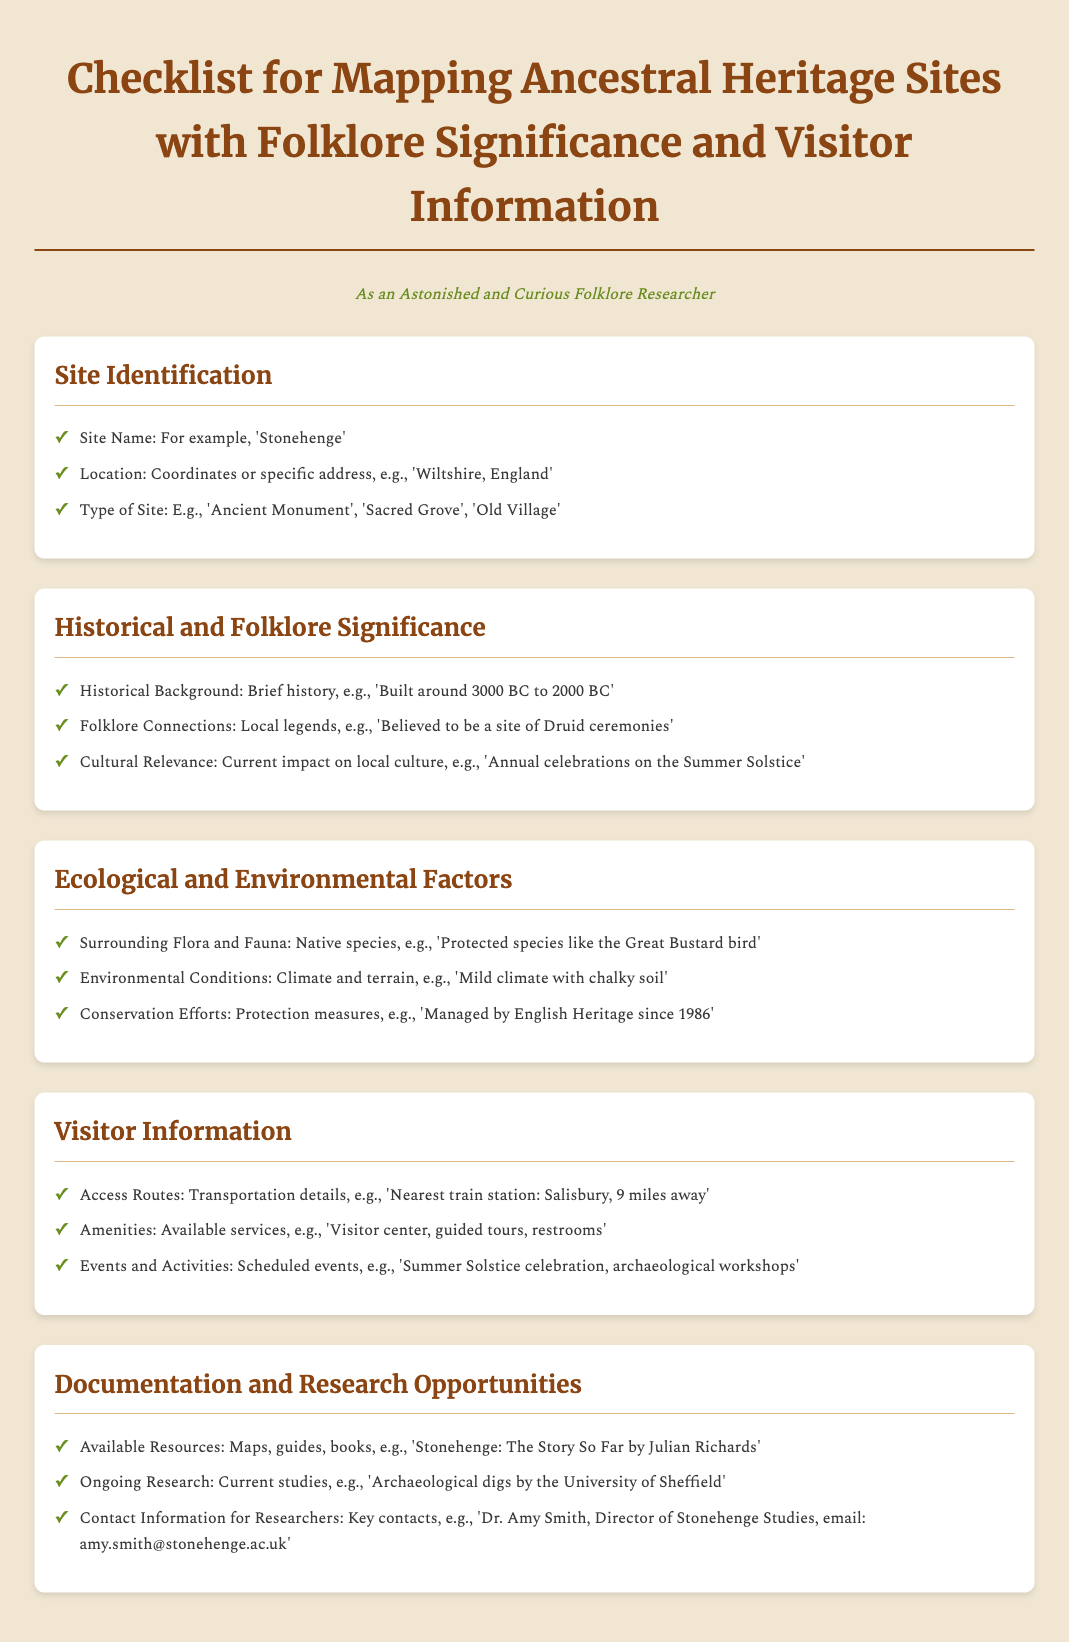What is an example of a site name? The document provides an example of a site name as 'Stonehenge'.
Answer: Stonehenge What type of site is mentioned? The document lists examples of site types, including 'Ancient Monument'.
Answer: Ancient Monument What is the historical background timeframe? According to the document, the historical background of the site is specified as 'Built around 3000 BC to 2000 BC'.
Answer: Built around 3000 BC to 2000 BC What is a key folklore connection? The document states a folklore connection as 'Believed to be a site of Druid ceremonies'.
Answer: Believed to be a site of Druid ceremonies What are the available amenities? The document mentions available amenities, including 'Visitor center, guided tours, restrooms'.
Answer: Visitor center, guided tours, restrooms How far is the nearest train station? The document indicates that the nearest train station is 'Salisbury, 9 miles away'.
Answer: Salisbury, 9 miles away What ongoing research is mentioned? The document refers to 'Archaeological digs by the University of Sheffield' as ongoing research.
Answer: Archaeological digs by the University of Sheffield Who is a key contact for researchers? The document lists 'Dr. Amy Smith' as a key contact for researchers.
Answer: Dr. Amy Smith What is one of the summer events mentioned? The document includes 'Summer Solstice celebration' as one of the events.
Answer: Summer Solstice celebration 